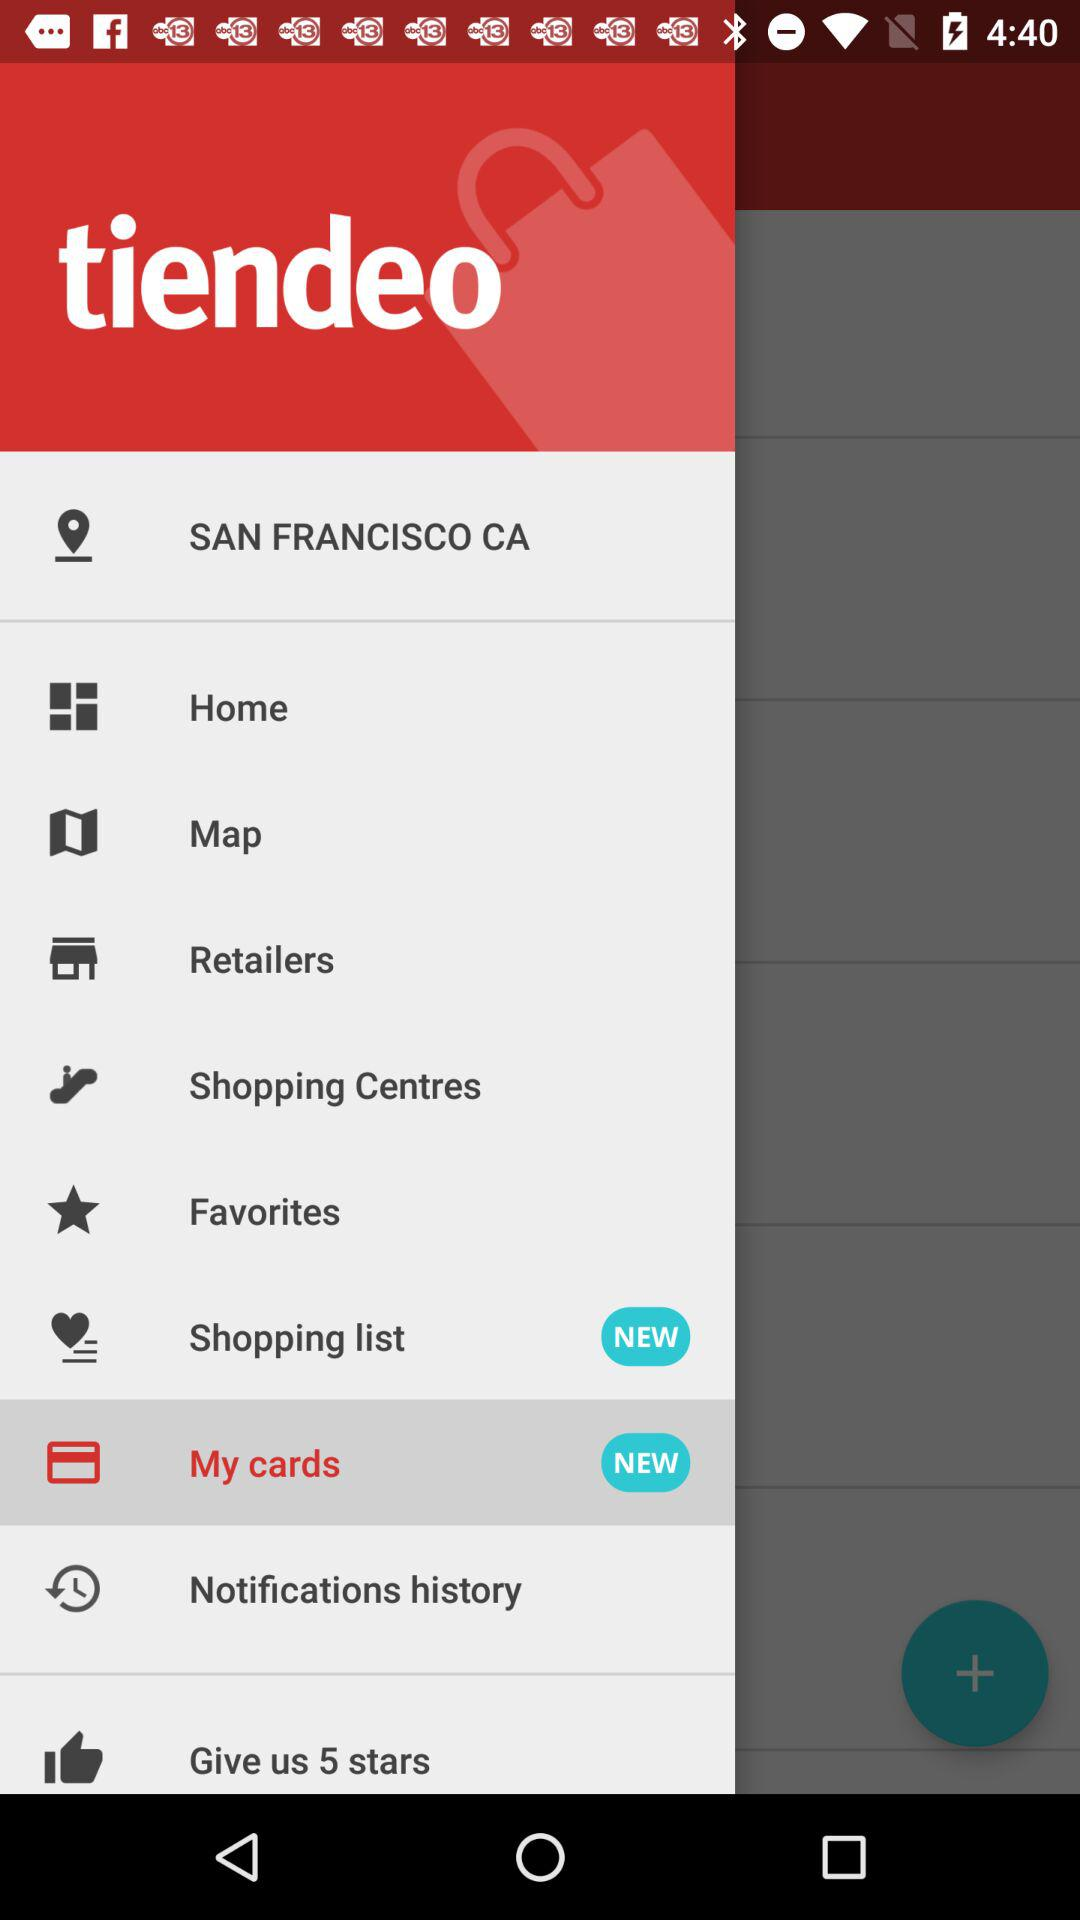How many items have NEW text on them?
Answer the question using a single word or phrase. 2 